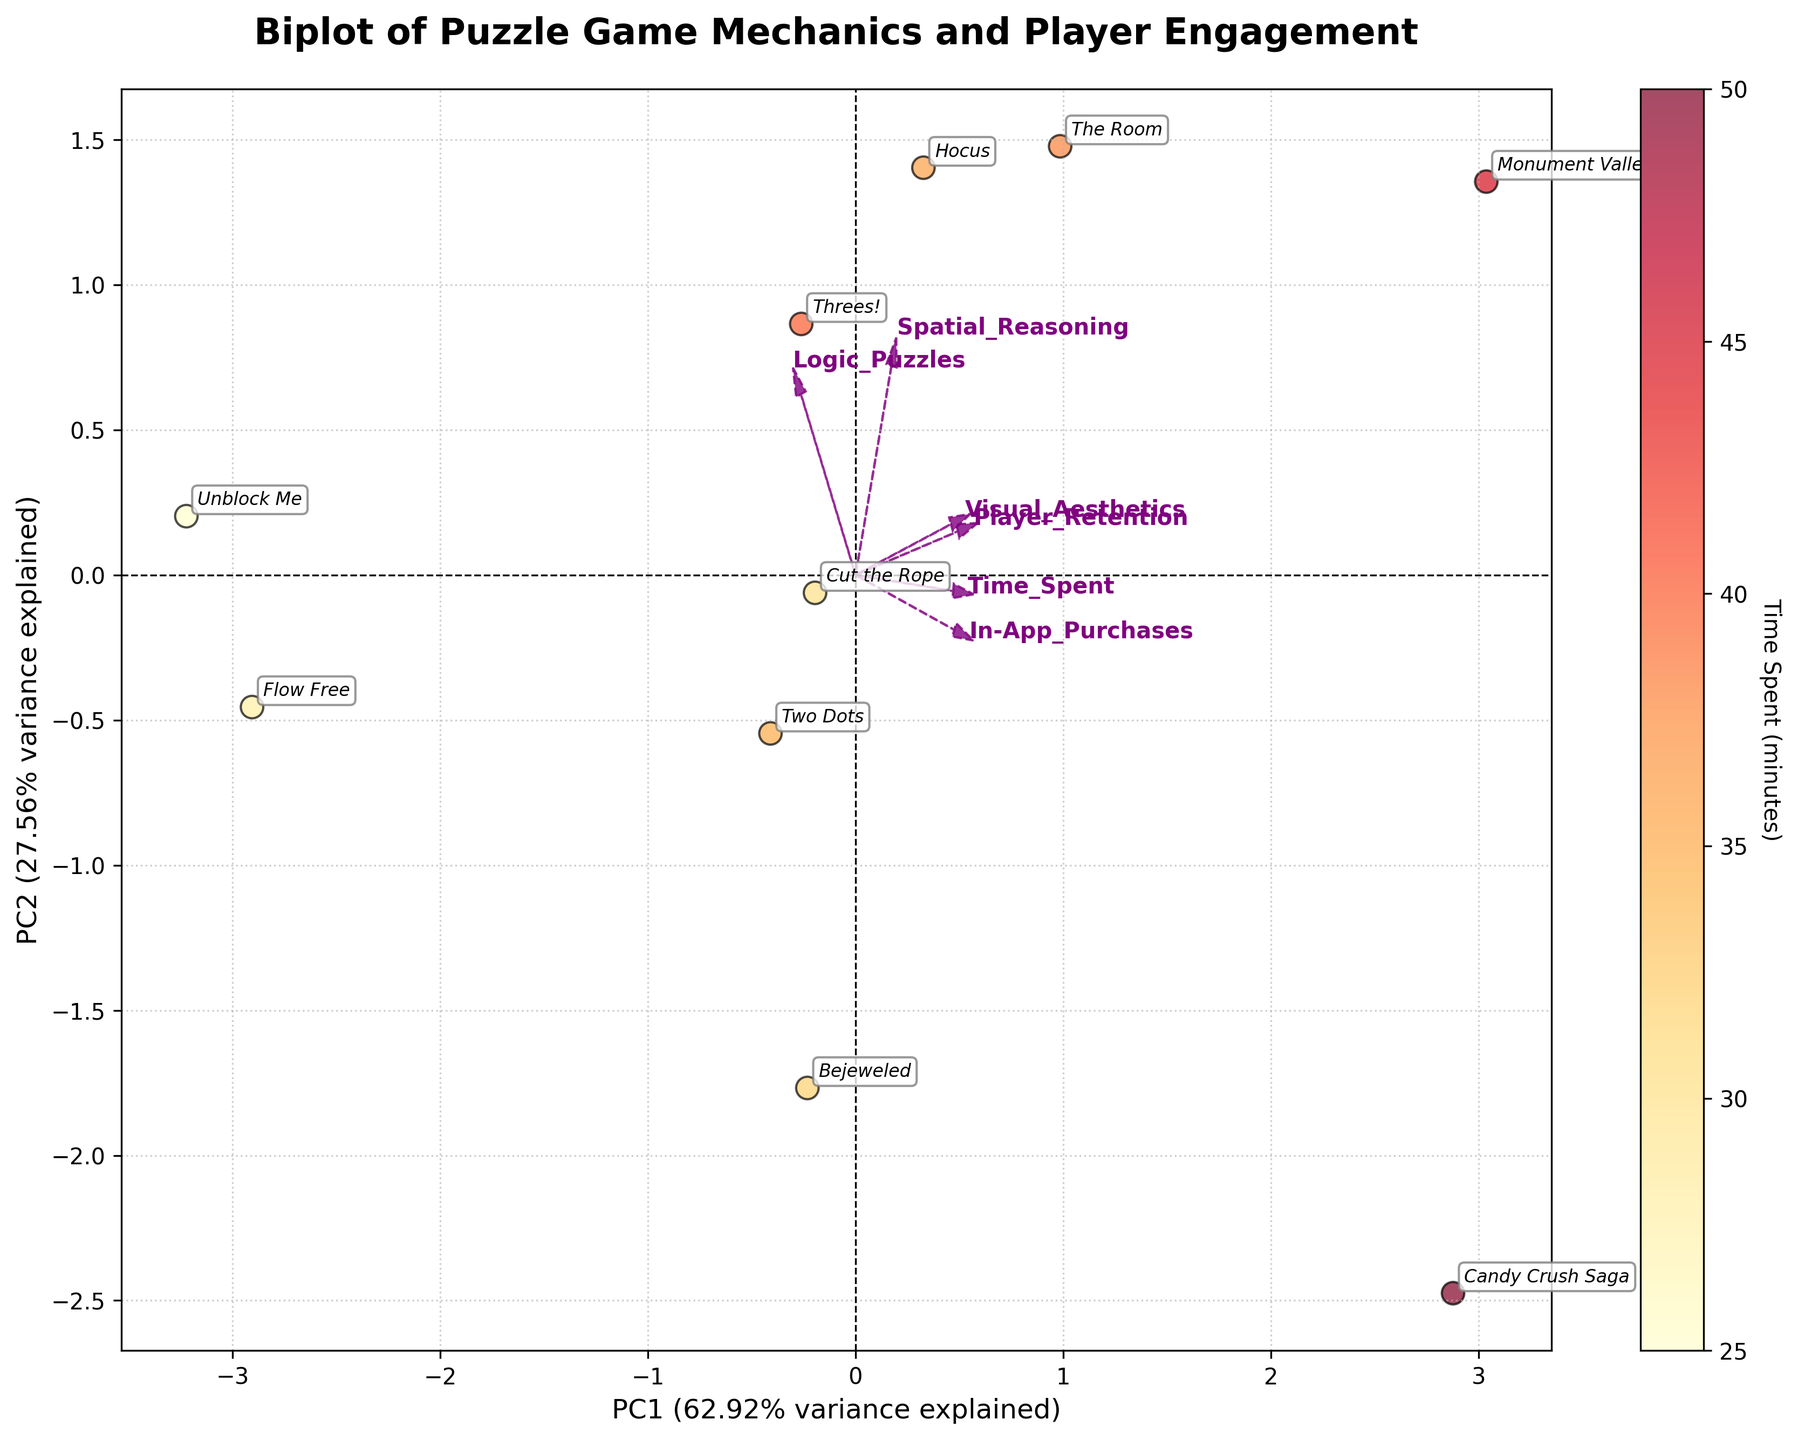What is the title of the plot? The title is located at the top center of the plot and is typically in a larger and bold font for emphasis.
Answer: Biplot of Puzzle Game Mechanics and Player Engagement How many games are plotted on the biplot? The plot contains annotations for each game, which are labeled in italics. By counting the labels, we can determine the number of games.
Answer: 10 Which game has the highest score in "Time Spent"? The color bar indicates "Time Spent," and by looking at the color intensity of each point, we find the most intense color.
Answer: Candy Crush Saga Which feature vector has the longest arrow? Inspecting the length of the arrows representing feature vectors, the longest one stands out.
Answer: Visual_Aesthetics Do "Spatial_Reasoning" and "Logic_Puzzles" contribute more to PC1 or PC2? By observing the direction and magnitude of the arrows for these feature vectors along the axes, we can determine their contribution. Both vectors lean more towards PC1.
Answer: PC1 Which game is closest to the origin? The origin is at (0, 0). Checking the annotations and their positions helps us find the game nearest to this point.
Answer: Unblock Me How is "Player_Retention" related to "Time_Spent" based on the biplot? Observing the directions and lengths of the arrows for "Player_Retention" and "Time_Spent," we can infer if they are aligned or orthogonal, indicating correlation or lack thereof. Both arrows point in the same general direction, suggesting a positive correlation.
Answer: Positively correlated Which game has the highest "Player_Retention" score? Player retention can be inferred from the direction and relative position of the games along the "Player_Retention" vector. Among the plotted games near this vector, by inspecting the annotations, "Monument Valley" appears closest.
Answer: Monument Valley Which games have vector components aligned with "Visual_Aesthetics" and why? By checking the direction of the "Visual_Aesthetics" vector, we can match it with the games that are projected most closely along that line. Monument Valley and Hocus align well due to their high visual aesthetics scores shown by their position relative to the vector.
Answer: Monument Valley, Hocus What percentage of variance is explained by PC1 and PC2 combined? The axes labels for PC1 and PC2 specify the explained variance percentage for each. Adding these percentages gives the total explained variance.
Answer: 73% 